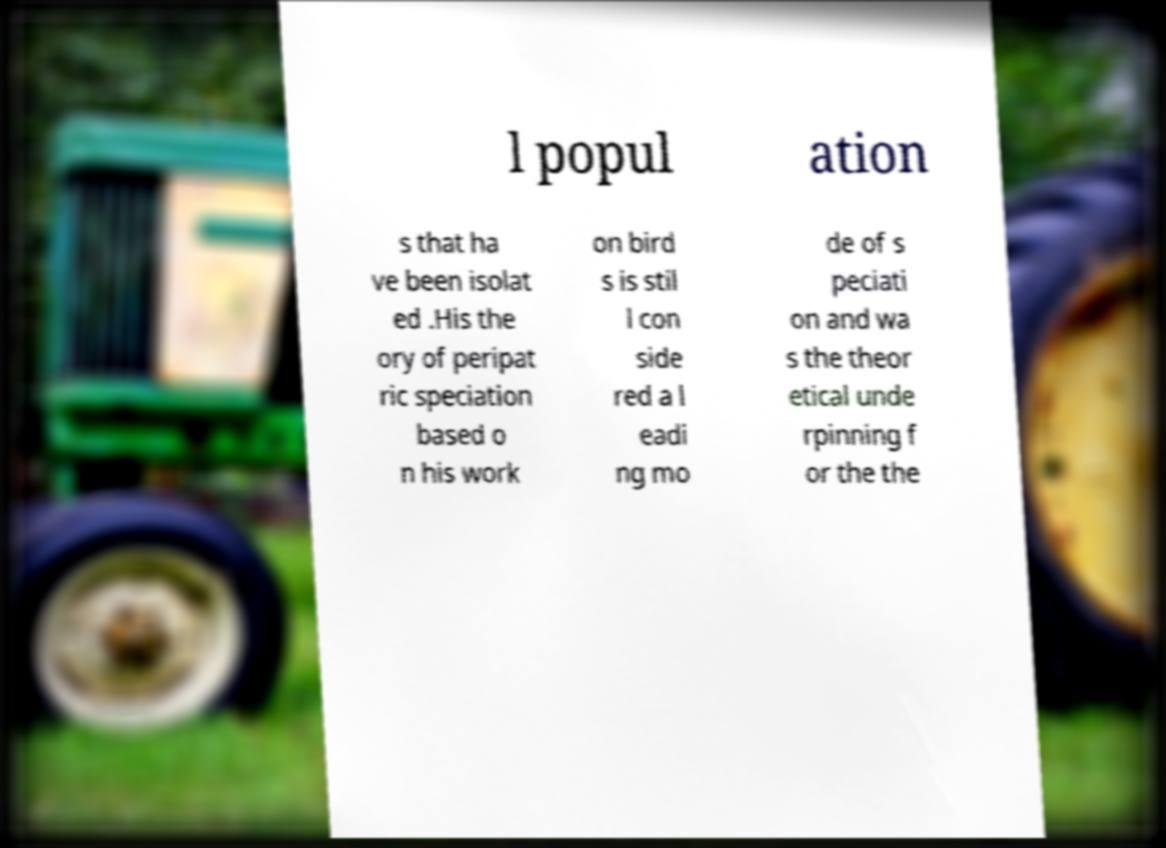Could you extract and type out the text from this image? l popul ation s that ha ve been isolat ed .His the ory of peripat ric speciation based o n his work on bird s is stil l con side red a l eadi ng mo de of s peciati on and wa s the theor etical unde rpinning f or the the 